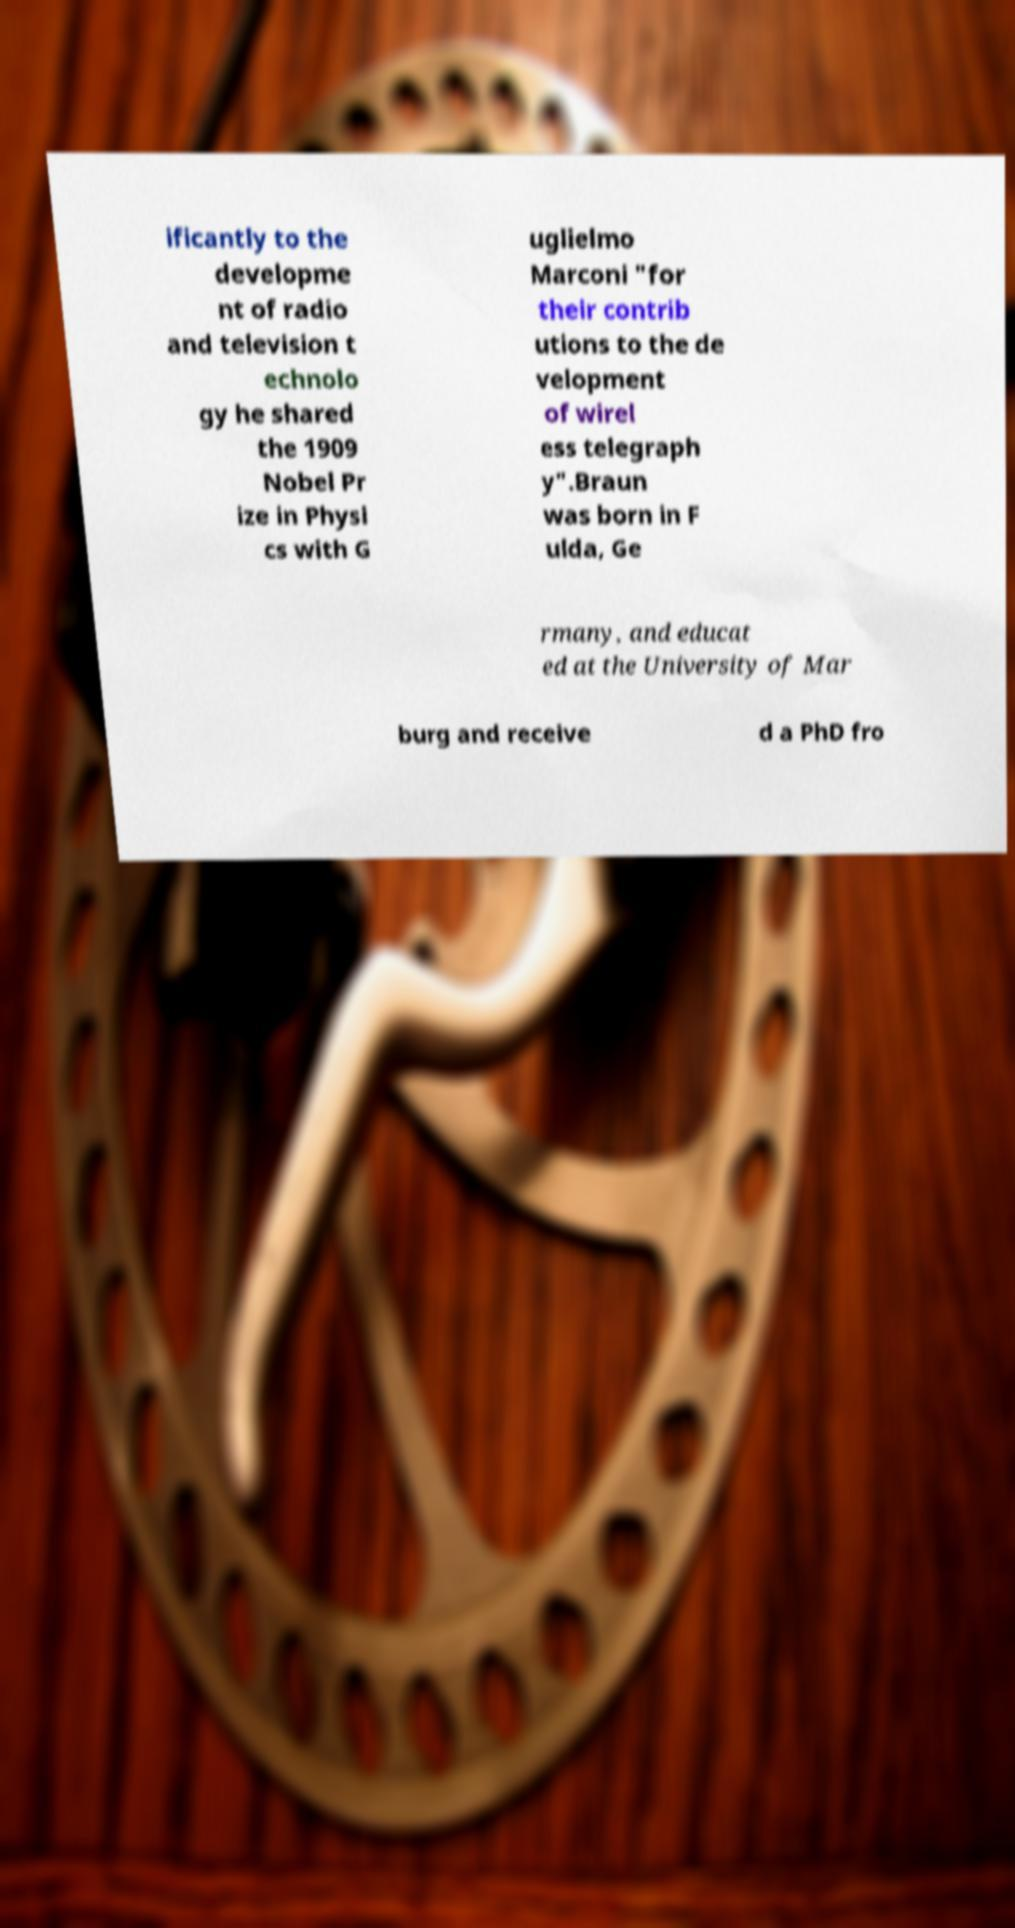Please read and relay the text visible in this image. What does it say? ificantly to the developme nt of radio and television t echnolo gy he shared the 1909 Nobel Pr ize in Physi cs with G uglielmo Marconi "for their contrib utions to the de velopment of wirel ess telegraph y".Braun was born in F ulda, Ge rmany, and educat ed at the University of Mar burg and receive d a PhD fro 